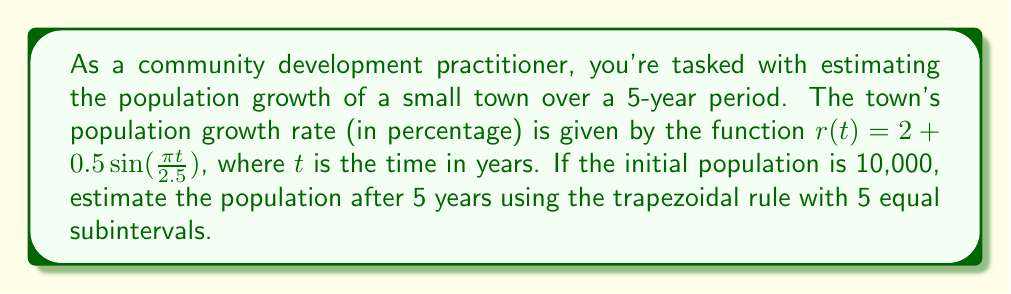Teach me how to tackle this problem. To solve this problem, we'll use the trapezoidal rule for numerical integration. The steps are as follows:

1) The population growth is described by the differential equation:
   $$\frac{dP}{dt} = \frac{r(t)}{100}P$$

2) Solving this equation gives:
   $$P(t) = P_0 e^{\int_0^t \frac{r(s)}{100} ds}$$

3) We need to estimate the integral $\int_0^5 \frac{r(t)}{100} dt$ using the trapezoidal rule with 5 subintervals.

4) The trapezoidal rule formula is:
   $$\int_a^b f(x)dx \approx \frac{h}{2}[f(x_0) + 2f(x_1) + 2f(x_2) + ... + 2f(x_{n-1}) + f(x_n)]$$
   where $h = \frac{b-a}{n}$, and $n$ is the number of subintervals.

5) In our case, $h = \frac{5-0}{5} = 1$, and we need to evaluate $\frac{r(t)}{100}$ at $t = 0, 1, 2, 3, 4, 5$.

6) Calculating the values:
   $\frac{r(0)}{100} = \frac{2 + 0.5\sin(0)}{100} = 0.02$
   $\frac{r(1)}{100} = \frac{2 + 0.5\sin(\frac{\pi}{2.5})}{100} \approx 0.0231$
   $\frac{r(2)}{100} = \frac{2 + 0.5\sin(\frac{2\pi}{2.5})}{100} \approx 0.0241$
   $\frac{r(3)}{100} = \frac{2 + 0.5\sin(\frac{3\pi}{2.5})}{100} \approx 0.0231$
   $\frac{r(4)}{100} = \frac{2 + 0.5\sin(\frac{4\pi}{2.5})}{100} \approx 0.0206$
   $\frac{r(5)}{100} = \frac{2 + 0.5\sin(2\pi)}{100} = 0.02$

7) Applying the trapezoidal rule:
   $$\int_0^5 \frac{r(t)}{100} dt \approx \frac{1}{2}[0.02 + 2(0.0231 + 0.0241 + 0.0231 + 0.0206) + 0.02] \approx 0.1109$$

8) Therefore, $P(5) \approx 10000 e^{0.1109} \approx 11172$
Answer: 11,172 people 